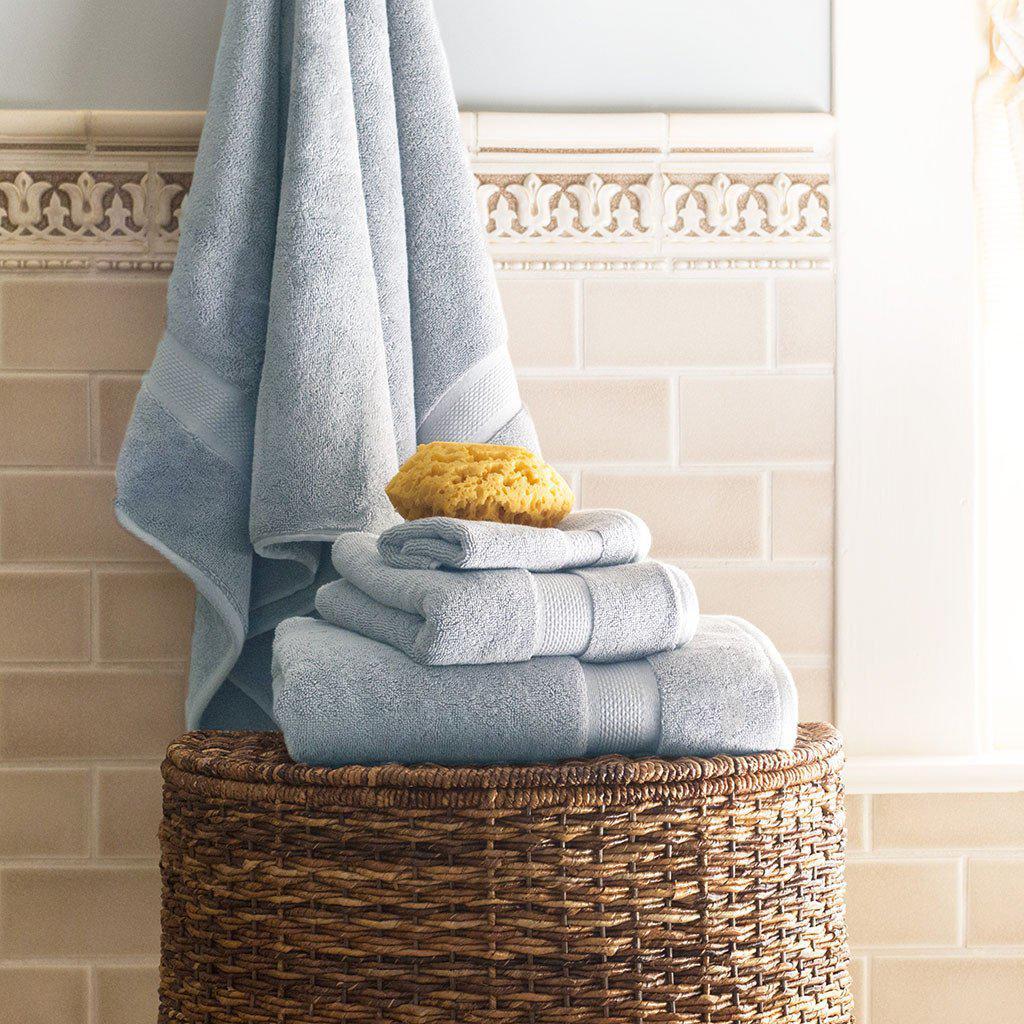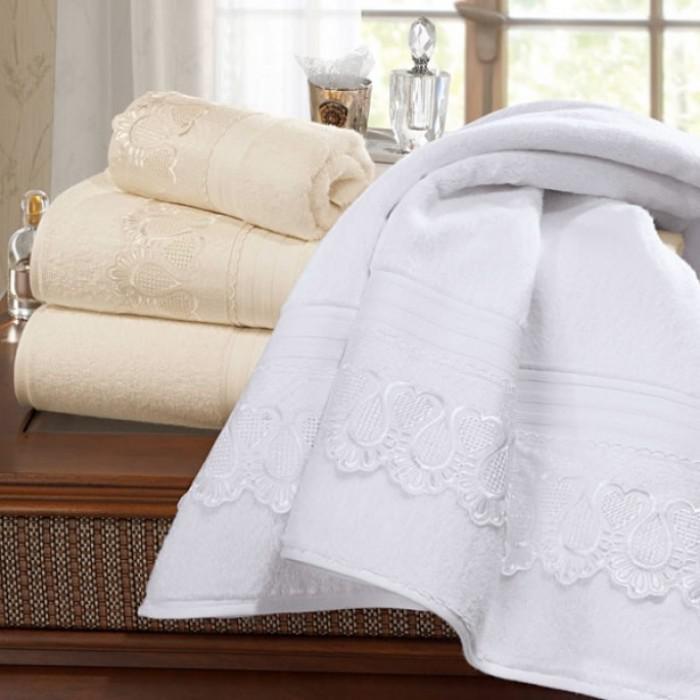The first image is the image on the left, the second image is the image on the right. Considering the images on both sides, is "IN at least one image there is a tower of six folded towels." valid? Answer yes or no. No. The first image is the image on the left, the second image is the image on the right. Evaluate the accuracy of this statement regarding the images: "In one image, six towels the same color are folded and stacked according to size, smallest on top.". Is it true? Answer yes or no. No. 